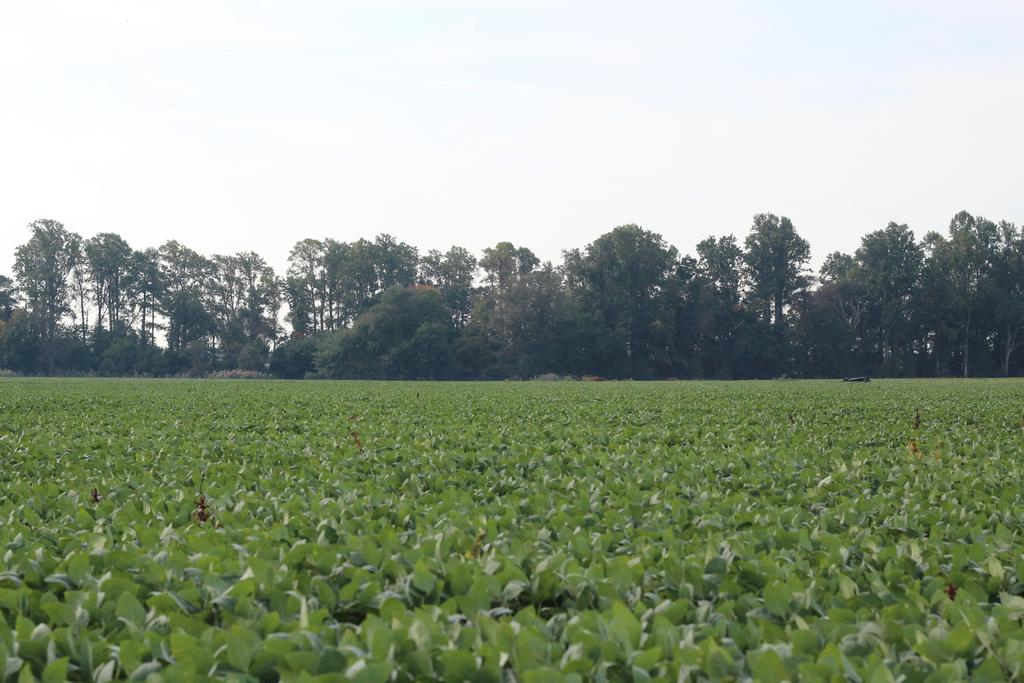What type of vegetation is present in the image? There are leaves in the image. What structures are visible in the image? There are trees in the image. What part of the natural environment is visible in the background of the image? The sky is visible in the background of the image. Can you see any ghosts in the image? There are no ghosts present in the image. What type of waterfowl can be seen swimming in the image? There are no ducks present in the image. What type of container is visible in the image? There is no basket present in the image. 